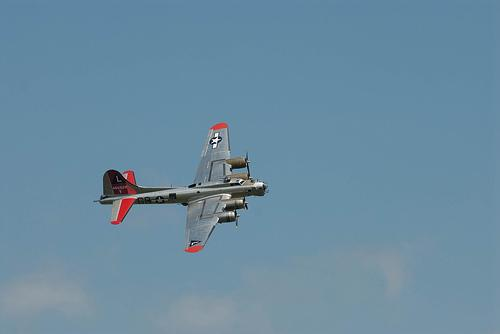Mention the position of the propeller in relation to the plane. The propeller is at the front of the plane. List three components of the airplane you can see in this image. Wings, back wings, and the propeller. Can you describe the color and design of the airplane? The airplane is silver and red in color. What seems to be the orientation of the airplane in the sky? The airplane is flying on its side in the sky. Explain one possible complex reasoning task that could be performed with this image. Predicting the trajectory of the airplane in the sky based on its current orientation, speed, and the presence of any nearby objects or obstacles. How many wings are visible in the image? There are two wings visible in the image. Provide a brief description of what's happening in this image. An airplane is flying on its side in the clear blue sky filled with white clouds. Briefly describe the emotions this image might evoke. The image might evoke feelings of excitement, freedom, and adventure. Are there any noticeable clouds in the sky, and if so, what do they look like? Yes, there are white clouds in the blue sky. What type of sky is visible in the image and are there any clouds present? It's a clear blue sky with white clouds scattered around. 